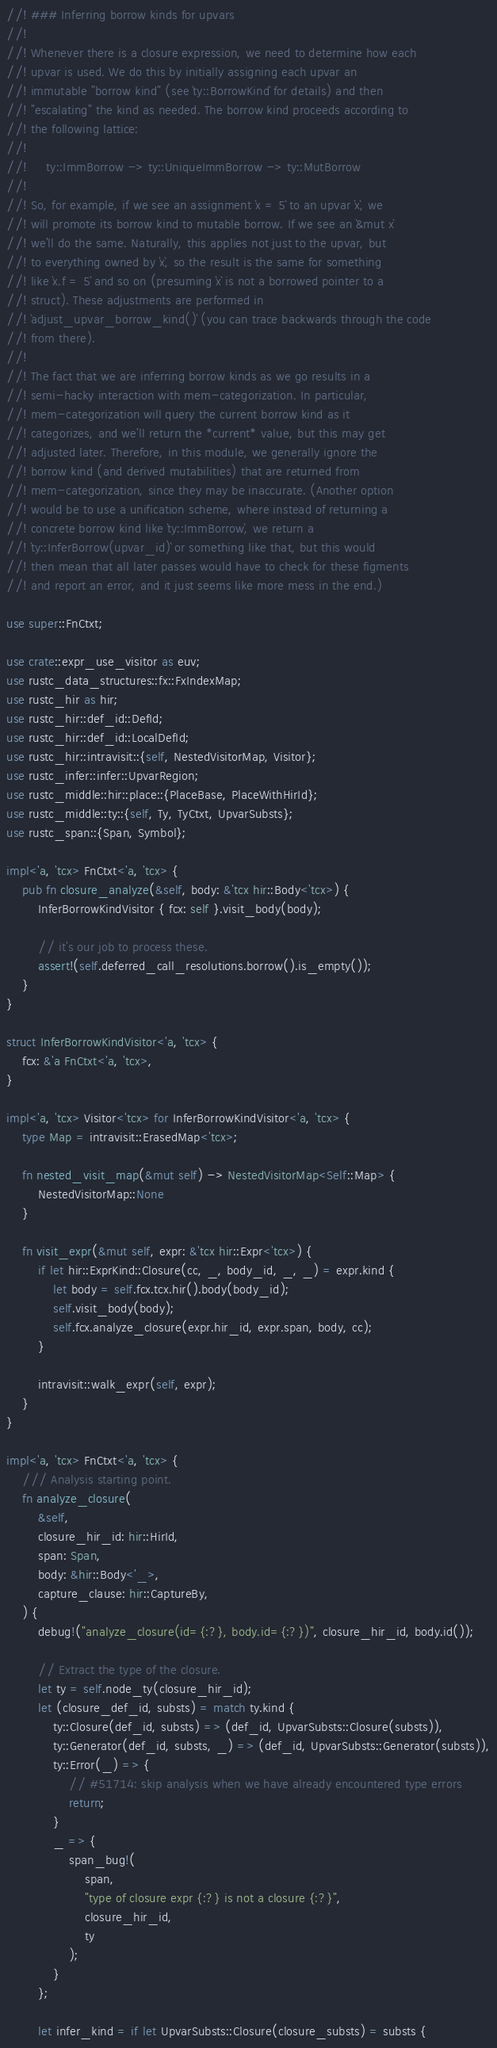<code> <loc_0><loc_0><loc_500><loc_500><_Rust_>//! ### Inferring borrow kinds for upvars
//!
//! Whenever there is a closure expression, we need to determine how each
//! upvar is used. We do this by initially assigning each upvar an
//! immutable "borrow kind" (see `ty::BorrowKind` for details) and then
//! "escalating" the kind as needed. The borrow kind proceeds according to
//! the following lattice:
//!
//!     ty::ImmBorrow -> ty::UniqueImmBorrow -> ty::MutBorrow
//!
//! So, for example, if we see an assignment `x = 5` to an upvar `x`, we
//! will promote its borrow kind to mutable borrow. If we see an `&mut x`
//! we'll do the same. Naturally, this applies not just to the upvar, but
//! to everything owned by `x`, so the result is the same for something
//! like `x.f = 5` and so on (presuming `x` is not a borrowed pointer to a
//! struct). These adjustments are performed in
//! `adjust_upvar_borrow_kind()` (you can trace backwards through the code
//! from there).
//!
//! The fact that we are inferring borrow kinds as we go results in a
//! semi-hacky interaction with mem-categorization. In particular,
//! mem-categorization will query the current borrow kind as it
//! categorizes, and we'll return the *current* value, but this may get
//! adjusted later. Therefore, in this module, we generally ignore the
//! borrow kind (and derived mutabilities) that are returned from
//! mem-categorization, since they may be inaccurate. (Another option
//! would be to use a unification scheme, where instead of returning a
//! concrete borrow kind like `ty::ImmBorrow`, we return a
//! `ty::InferBorrow(upvar_id)` or something like that, but this would
//! then mean that all later passes would have to check for these figments
//! and report an error, and it just seems like more mess in the end.)

use super::FnCtxt;

use crate::expr_use_visitor as euv;
use rustc_data_structures::fx::FxIndexMap;
use rustc_hir as hir;
use rustc_hir::def_id::DefId;
use rustc_hir::def_id::LocalDefId;
use rustc_hir::intravisit::{self, NestedVisitorMap, Visitor};
use rustc_infer::infer::UpvarRegion;
use rustc_middle::hir::place::{PlaceBase, PlaceWithHirId};
use rustc_middle::ty::{self, Ty, TyCtxt, UpvarSubsts};
use rustc_span::{Span, Symbol};

impl<'a, 'tcx> FnCtxt<'a, 'tcx> {
    pub fn closure_analyze(&self, body: &'tcx hir::Body<'tcx>) {
        InferBorrowKindVisitor { fcx: self }.visit_body(body);

        // it's our job to process these.
        assert!(self.deferred_call_resolutions.borrow().is_empty());
    }
}

struct InferBorrowKindVisitor<'a, 'tcx> {
    fcx: &'a FnCtxt<'a, 'tcx>,
}

impl<'a, 'tcx> Visitor<'tcx> for InferBorrowKindVisitor<'a, 'tcx> {
    type Map = intravisit::ErasedMap<'tcx>;

    fn nested_visit_map(&mut self) -> NestedVisitorMap<Self::Map> {
        NestedVisitorMap::None
    }

    fn visit_expr(&mut self, expr: &'tcx hir::Expr<'tcx>) {
        if let hir::ExprKind::Closure(cc, _, body_id, _, _) = expr.kind {
            let body = self.fcx.tcx.hir().body(body_id);
            self.visit_body(body);
            self.fcx.analyze_closure(expr.hir_id, expr.span, body, cc);
        }

        intravisit::walk_expr(self, expr);
    }
}

impl<'a, 'tcx> FnCtxt<'a, 'tcx> {
    /// Analysis starting point.
    fn analyze_closure(
        &self,
        closure_hir_id: hir::HirId,
        span: Span,
        body: &hir::Body<'_>,
        capture_clause: hir::CaptureBy,
    ) {
        debug!("analyze_closure(id={:?}, body.id={:?})", closure_hir_id, body.id());

        // Extract the type of the closure.
        let ty = self.node_ty(closure_hir_id);
        let (closure_def_id, substs) = match ty.kind {
            ty::Closure(def_id, substs) => (def_id, UpvarSubsts::Closure(substs)),
            ty::Generator(def_id, substs, _) => (def_id, UpvarSubsts::Generator(substs)),
            ty::Error(_) => {
                // #51714: skip analysis when we have already encountered type errors
                return;
            }
            _ => {
                span_bug!(
                    span,
                    "type of closure expr {:?} is not a closure {:?}",
                    closure_hir_id,
                    ty
                );
            }
        };

        let infer_kind = if let UpvarSubsts::Closure(closure_substs) = substs {</code> 